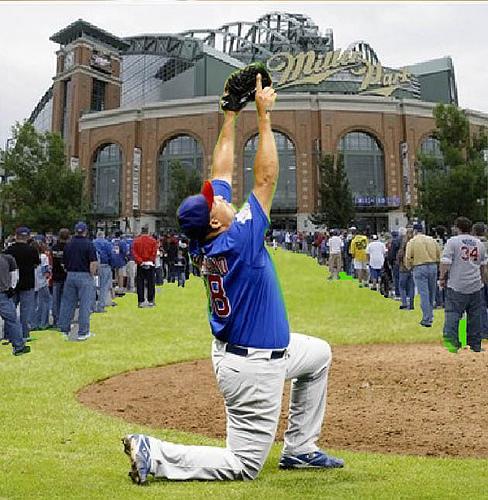What is Miller Park?
Concise answer only. Baseball field. Are they standing on a playing field?
Write a very short answer. Yes. Is he praying?
Short answer required. No. 